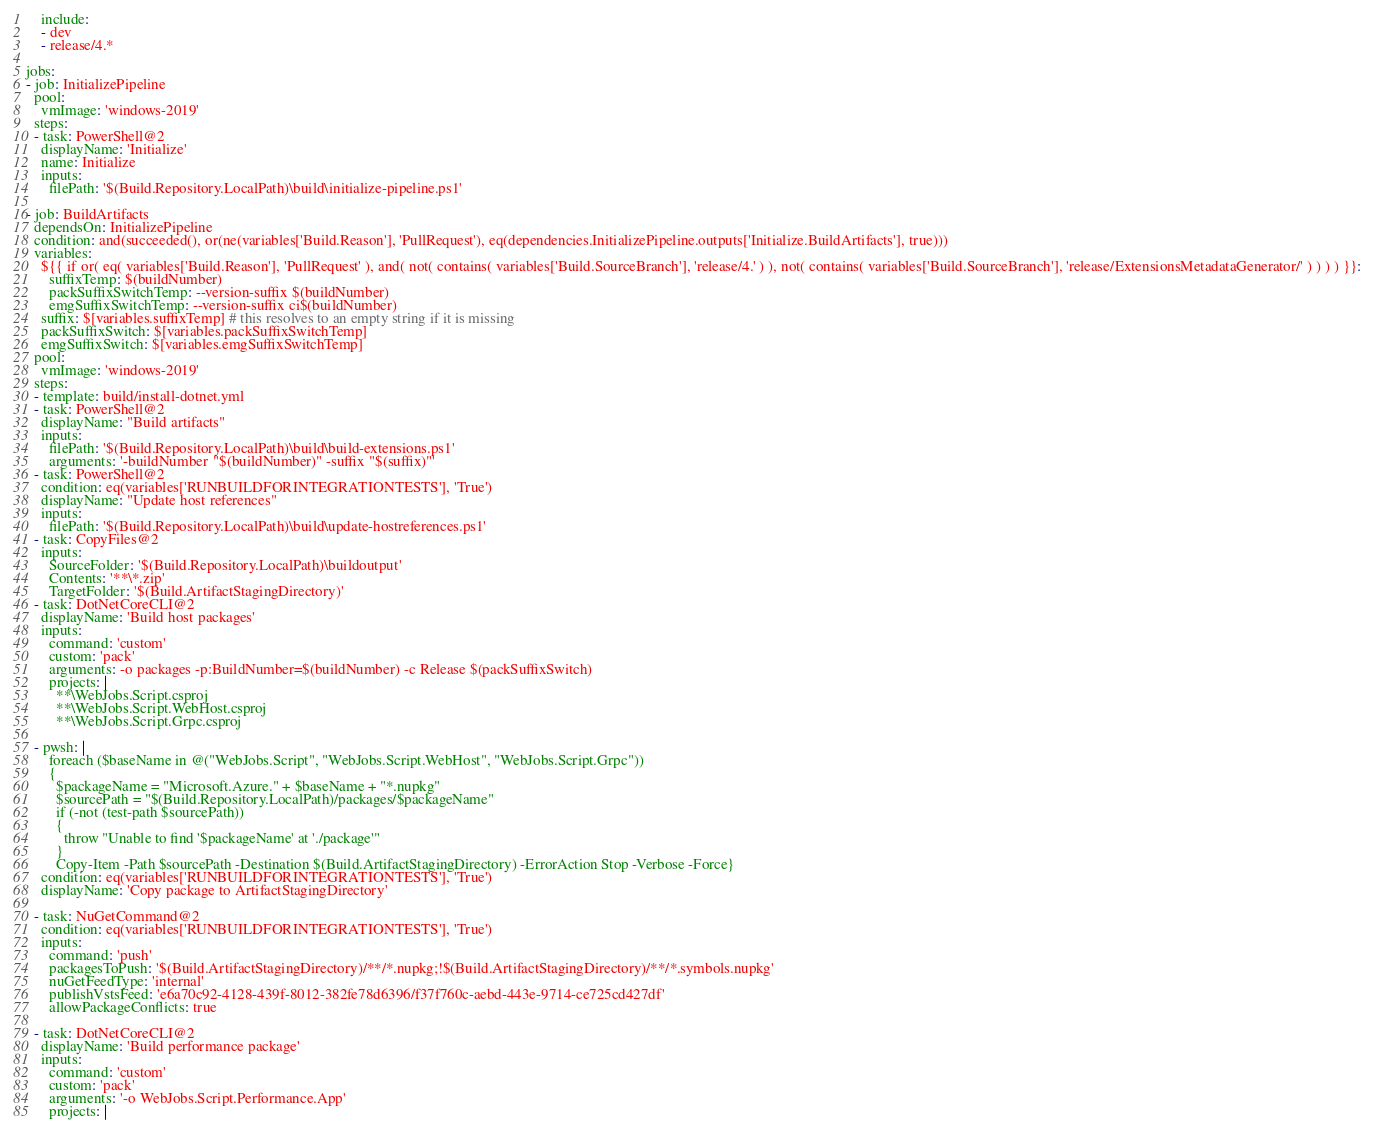<code> <loc_0><loc_0><loc_500><loc_500><_YAML_>    include:
    - dev
    - release/4.*

jobs:
- job: InitializePipeline
  pool:
    vmImage: 'windows-2019'
  steps:
  - task: PowerShell@2
    displayName: 'Initialize'
    name: Initialize
    inputs:
      filePath: '$(Build.Repository.LocalPath)\build\initialize-pipeline.ps1'

- job: BuildArtifacts
  dependsOn: InitializePipeline
  condition: and(succeeded(), or(ne(variables['Build.Reason'], 'PullRequest'), eq(dependencies.InitializePipeline.outputs['Initialize.BuildArtifacts'], true)))
  variables:
    ${{ if or( eq( variables['Build.Reason'], 'PullRequest' ), and( not( contains( variables['Build.SourceBranch'], 'release/4.' ) ), not( contains( variables['Build.SourceBranch'], 'release/ExtensionsMetadataGenerator/' ) ) ) ) }}:
      suffixTemp: $(buildNumber)
      packSuffixSwitchTemp: --version-suffix $(buildNumber)
      emgSuffixSwitchTemp: --version-suffix ci$(buildNumber)
    suffix: $[variables.suffixTemp] # this resolves to an empty string if it is missing
    packSuffixSwitch: $[variables.packSuffixSwitchTemp]
    emgSuffixSwitch: $[variables.emgSuffixSwitchTemp]
  pool:
    vmImage: 'windows-2019'
  steps:
  - template: build/install-dotnet.yml
  - task: PowerShell@2
    displayName: "Build artifacts"
    inputs:
      filePath: '$(Build.Repository.LocalPath)\build\build-extensions.ps1'
      arguments: '-buildNumber "$(buildNumber)" -suffix "$(suffix)"'
  - task: PowerShell@2
    condition: eq(variables['RUNBUILDFORINTEGRATIONTESTS'], 'True')
    displayName: "Update host references"
    inputs:
      filePath: '$(Build.Repository.LocalPath)\build\update-hostreferences.ps1'
  - task: CopyFiles@2
    inputs:
      SourceFolder: '$(Build.Repository.LocalPath)\buildoutput'
      Contents: '**\*.zip'
      TargetFolder: '$(Build.ArtifactStagingDirectory)'
  - task: DotNetCoreCLI@2
    displayName: 'Build host packages'
    inputs:
      command: 'custom'
      custom: 'pack'
      arguments: -o packages -p:BuildNumber=$(buildNumber) -c Release $(packSuffixSwitch)
      projects: |
        **\WebJobs.Script.csproj
        **\WebJobs.Script.WebHost.csproj
        **\WebJobs.Script.Grpc.csproj

  - pwsh: |
      foreach ($baseName in @("WebJobs.Script", "WebJobs.Script.WebHost", "WebJobs.Script.Grpc"))
      {
        $packageName = "Microsoft.Azure." + $baseName + "*.nupkg"
        $sourcePath = "$(Build.Repository.LocalPath)/packages/$packageName"
        if (-not (test-path $sourcePath))
        {
          throw "Unable to find '$packageName' at './package'"
        }
        Copy-Item -Path $sourcePath -Destination $(Build.ArtifactStagingDirectory) -ErrorAction Stop -Verbose -Force}
    condition: eq(variables['RUNBUILDFORINTEGRATIONTESTS'], 'True')
    displayName: 'Copy package to ArtifactStagingDirectory'

  - task: NuGetCommand@2
    condition: eq(variables['RUNBUILDFORINTEGRATIONTESTS'], 'True')
    inputs:
      command: 'push'
      packagesToPush: '$(Build.ArtifactStagingDirectory)/**/*.nupkg;!$(Build.ArtifactStagingDirectory)/**/*.symbols.nupkg'
      nuGetFeedType: 'internal'
      publishVstsFeed: 'e6a70c92-4128-439f-8012-382fe78d6396/f37f760c-aebd-443e-9714-ce725cd427df'
      allowPackageConflicts: true

  - task: DotNetCoreCLI@2
    displayName: 'Build performance package'
    inputs:
      command: 'custom'
      custom: 'pack'
      arguments: '-o WebJobs.Script.Performance.App'
      projects: |</code> 